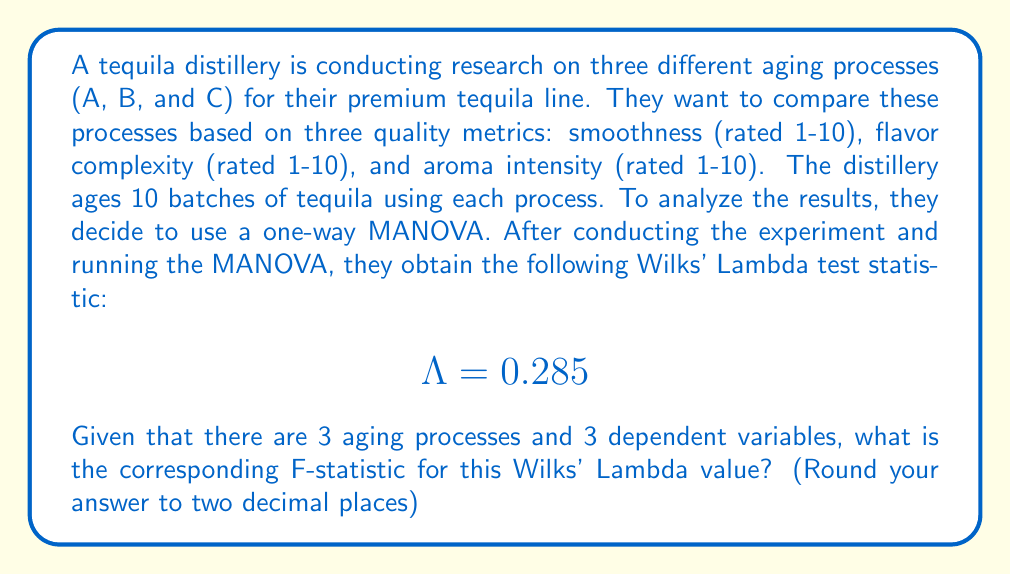Help me with this question. To solve this problem, we need to follow these steps:

1. Identify the parameters:
   - Number of groups (aging processes) = 3
   - Number of dependent variables = 3
   - Wilks' Lambda ($\Lambda$) = 0.285

2. Calculate the degrees of freedom:
   - Between-groups df: $df_1 = p(a-1)$, where $p$ is the number of dependent variables and $a$ is the number of groups
   - Within-groups df: $df_2 = wt - (p + a - 2)$, where $wt$ is the within-groups degrees of freedom

   $df_1 = 3(3-1) = 6$
   $df_2 = (30-3) - (3 + 3 - 2) = 23$

3. Use the formula to convert Wilks' Lambda to an F-statistic:

   $$F = \frac{1-\Lambda^{1/t}}{\Lambda^{1/t}} \cdot \frac{df_2}{df_1}$$

   Where $t = \sqrt{\frac{p^2(a-1)^2-4}{p^2+(a-1)^2-5}}$ if $p^2 + (a-1)^2 > 5$

4. Calculate $t$:
   $$t = \sqrt{\frac{3^2(3-1)^2-4}{3^2+(3-1)^2-5}} = \sqrt{\frac{32}{13}} = 1.5695$$

5. Now, let's substitute the values into the F-statistic formula:

   $$F = \frac{1-(0.285)^{1/1.5695}}{(0.285)^{1/1.5695}} \cdot \frac{23}{6}$$

6. Solve the equation:
   $$F = \frac{1-0.4634}{0.4634} \cdot \frac{23}{6}$$
   $$F = 1.1580 \cdot 3.8333$$
   $$F = 4.4391$$

7. Rounding to two decimal places:
   $$F \approx 4.44$$
Answer: The corresponding F-statistic is approximately 4.44. 